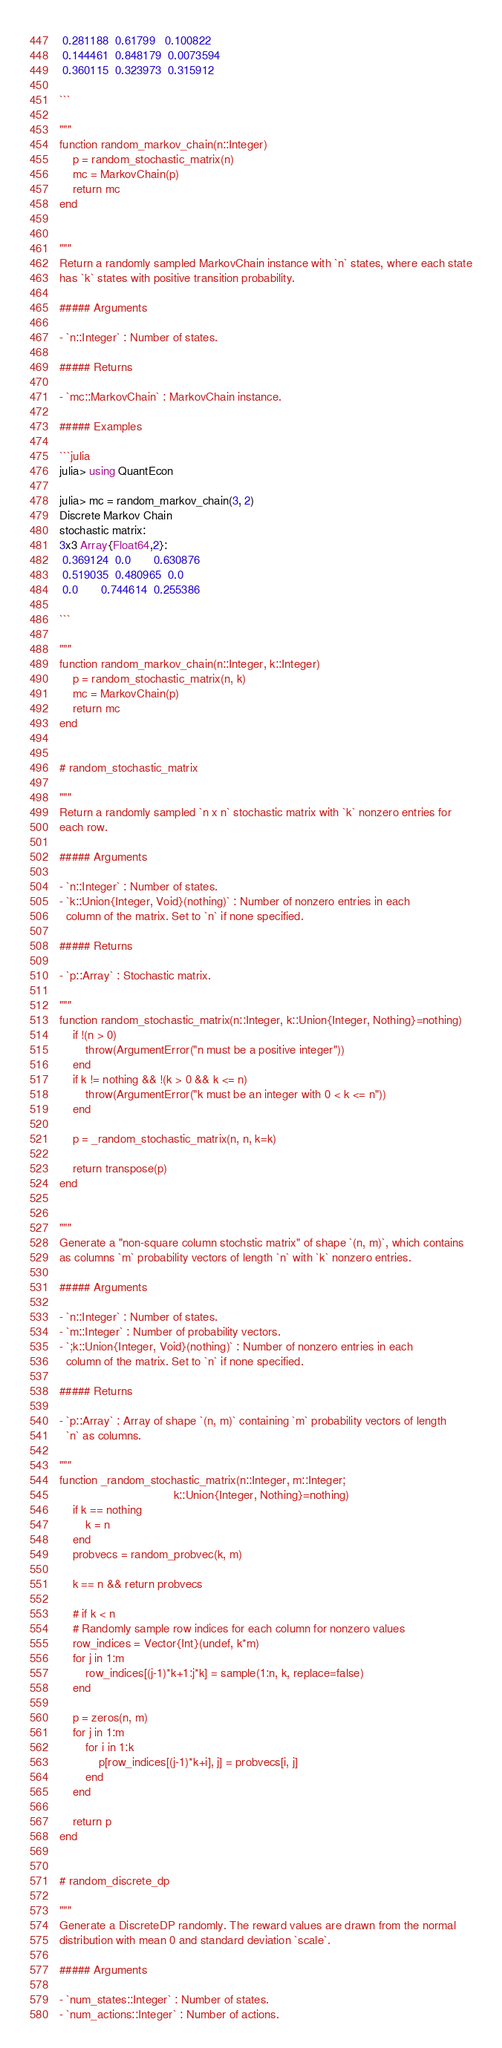Convert code to text. <code><loc_0><loc_0><loc_500><loc_500><_Julia_> 0.281188  0.61799   0.100822
 0.144461  0.848179  0.0073594
 0.360115  0.323973  0.315912

```

"""
function random_markov_chain(n::Integer)
    p = random_stochastic_matrix(n)
    mc = MarkovChain(p)
    return mc
end


"""
Return a randomly sampled MarkovChain instance with `n` states, where each state
has `k` states with positive transition probability.

##### Arguments

- `n::Integer` : Number of states.

##### Returns

- `mc::MarkovChain` : MarkovChain instance.

##### Examples

```julia
julia> using QuantEcon

julia> mc = random_markov_chain(3, 2)
Discrete Markov Chain
stochastic matrix:
3x3 Array{Float64,2}:
 0.369124  0.0       0.630876
 0.519035  0.480965  0.0
 0.0       0.744614  0.255386

```

"""
function random_markov_chain(n::Integer, k::Integer)
    p = random_stochastic_matrix(n, k)
    mc = MarkovChain(p)
    return mc
end


# random_stochastic_matrix

"""
Return a randomly sampled `n x n` stochastic matrix with `k` nonzero entries for
each row.

##### Arguments

- `n::Integer` : Number of states.
- `k::Union{Integer, Void}(nothing)` : Number of nonzero entries in each
  column of the matrix. Set to `n` if none specified.

##### Returns

- `p::Array` : Stochastic matrix.

"""
function random_stochastic_matrix(n::Integer, k::Union{Integer, Nothing}=nothing)
    if !(n > 0)
        throw(ArgumentError("n must be a positive integer"))
    end
    if k != nothing && !(k > 0 && k <= n)
        throw(ArgumentError("k must be an integer with 0 < k <= n"))
    end

    p = _random_stochastic_matrix(n, n, k=k)

    return transpose(p)
end


"""
Generate a "non-square column stochstic matrix" of shape `(n, m)`, which contains
as columns `m` probability vectors of length `n` with `k` nonzero entries.

##### Arguments

- `n::Integer` : Number of states.
- `m::Integer` : Number of probability vectors.
- `;k::Union{Integer, Void}(nothing)` : Number of nonzero entries in each
  column of the matrix. Set to `n` if none specified.

##### Returns

- `p::Array` : Array of shape `(n, m)` containing `m` probability vectors of length
  `n` as columns.

"""
function _random_stochastic_matrix(n::Integer, m::Integer;
                                   k::Union{Integer, Nothing}=nothing)
    if k == nothing
        k = n
    end
    probvecs = random_probvec(k, m)

    k == n && return probvecs

    # if k < n
    # Randomly sample row indices for each column for nonzero values
    row_indices = Vector{Int}(undef, k*m)
    for j in 1:m
        row_indices[(j-1)*k+1:j*k] = sample(1:n, k, replace=false)
    end

    p = zeros(n, m)
    for j in 1:m
        for i in 1:k
            p[row_indices[(j-1)*k+i], j] = probvecs[i, j]
        end
    end

    return p
end


# random_discrete_dp

"""
Generate a DiscreteDP randomly. The reward values are drawn from the normal
distribution with mean 0 and standard deviation `scale`.

##### Arguments

- `num_states::Integer` : Number of states.
- `num_actions::Integer` : Number of actions.</code> 